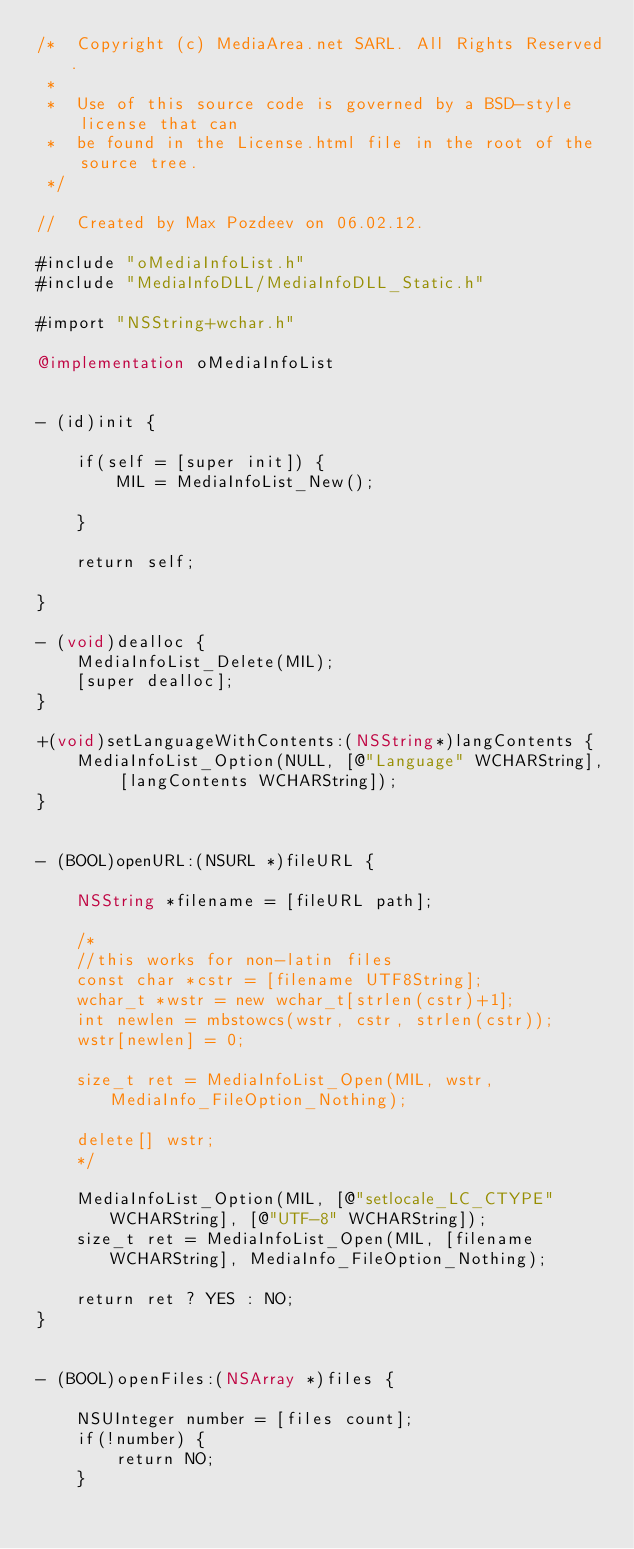Convert code to text. <code><loc_0><loc_0><loc_500><loc_500><_ObjectiveC_>/*  Copyright (c) MediaArea.net SARL. All Rights Reserved.
 *
 *  Use of this source code is governed by a BSD-style license that can
 *  be found in the License.html file in the root of the source tree.
 */

//  Created by Max Pozdeev on 06.02.12.

#include "oMediaInfoList.h"
#include "MediaInfoDLL/MediaInfoDLL_Static.h"

#import "NSString+wchar.h"

@implementation oMediaInfoList


- (id)init {
	
	if(self = [super init]) {
		MIL = MediaInfoList_New();
		
	}
	
	return self;
	
}

- (void)dealloc {
	MediaInfoList_Delete(MIL);
	[super dealloc];
}

+(void)setLanguageWithContents:(NSString*)langContents {
	MediaInfoList_Option(NULL, [@"Language" WCHARString], [langContents WCHARString]);
}


- (BOOL)openURL:(NSURL *)fileURL {
	
	NSString *filename = [fileURL path];

	/*
    //this works for non-latin files
	const char *cstr = [filename UTF8String];
	wchar_t *wstr = new wchar_t[strlen(cstr)+1];
	int newlen = mbstowcs(wstr, cstr, strlen(cstr));
	wstr[newlen] = 0;
	
	size_t ret = MediaInfoList_Open(MIL, wstr, MediaInfo_FileOption_Nothing);
	
	delete[] wstr;
	*/
	
	MediaInfoList_Option(MIL, [@"setlocale_LC_CTYPE" WCHARString], [@"UTF-8" WCHARString]);
	size_t ret = MediaInfoList_Open(MIL, [filename WCHARString], MediaInfo_FileOption_Nothing);
	
	return ret ? YES : NO;
}


- (BOOL)openFiles:(NSArray *)files {
	
	NSUInteger number = [files count];
	if(!number) {
		return NO;
	}
	</code> 